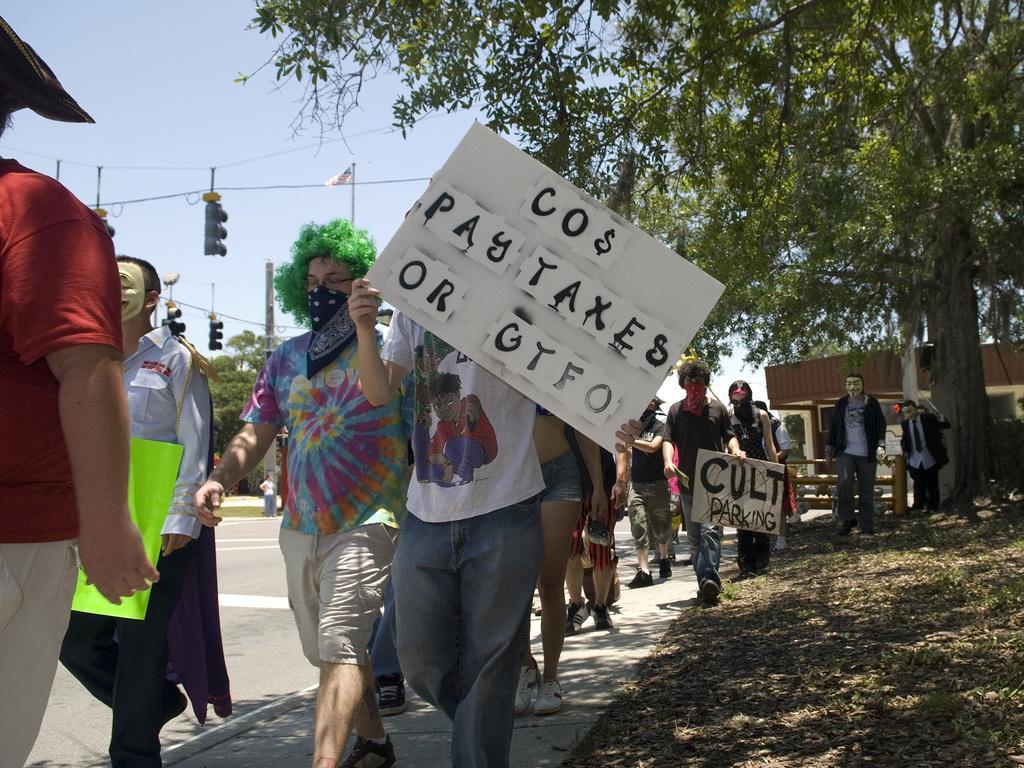Could you give a brief overview of what you see in this image? In this image we can see many people walking. Some are wearing mask. Some are holding placards. Also there are trees. In the back there is a building. Also there are trees. And there are traffic signals. And there is sky. 